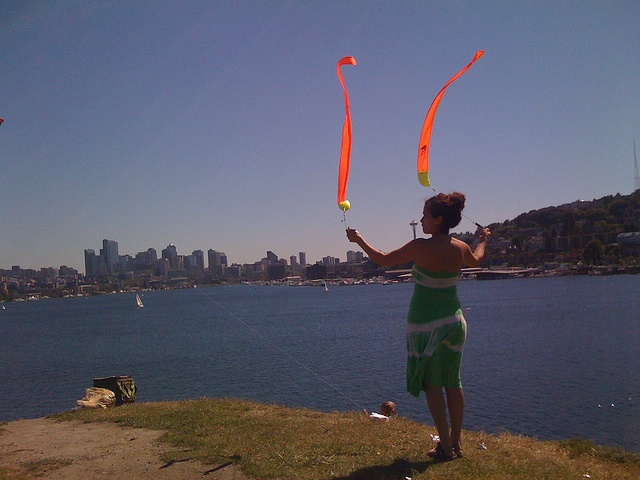Describe the objects in this image and their specific colors. I can see people in blue, black, maroon, gray, and darkgray tones, kite in blue, red, salmon, and brown tones, kite in blue, red, salmon, and brown tones, boat in blue, black, and gray tones, and boat in blue, gray, darkgray, and black tones in this image. 